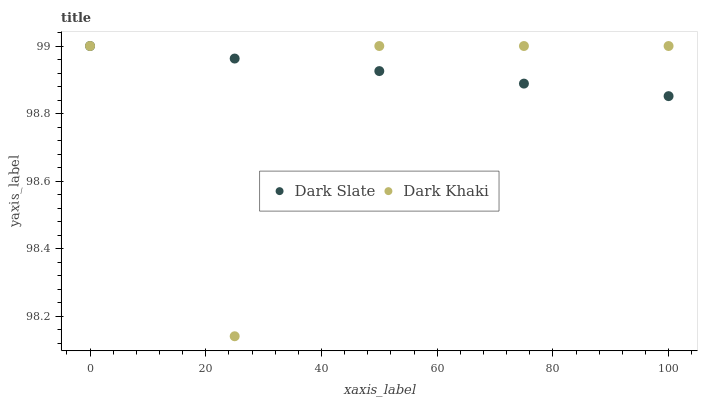Does Dark Khaki have the minimum area under the curve?
Answer yes or no. Yes. Does Dark Slate have the maximum area under the curve?
Answer yes or no. Yes. Does Dark Slate have the minimum area under the curve?
Answer yes or no. No. Is Dark Slate the smoothest?
Answer yes or no. Yes. Is Dark Khaki the roughest?
Answer yes or no. Yes. Is Dark Slate the roughest?
Answer yes or no. No. Does Dark Khaki have the lowest value?
Answer yes or no. Yes. Does Dark Slate have the lowest value?
Answer yes or no. No. Does Dark Slate have the highest value?
Answer yes or no. Yes. Does Dark Khaki intersect Dark Slate?
Answer yes or no. Yes. Is Dark Khaki less than Dark Slate?
Answer yes or no. No. Is Dark Khaki greater than Dark Slate?
Answer yes or no. No. 